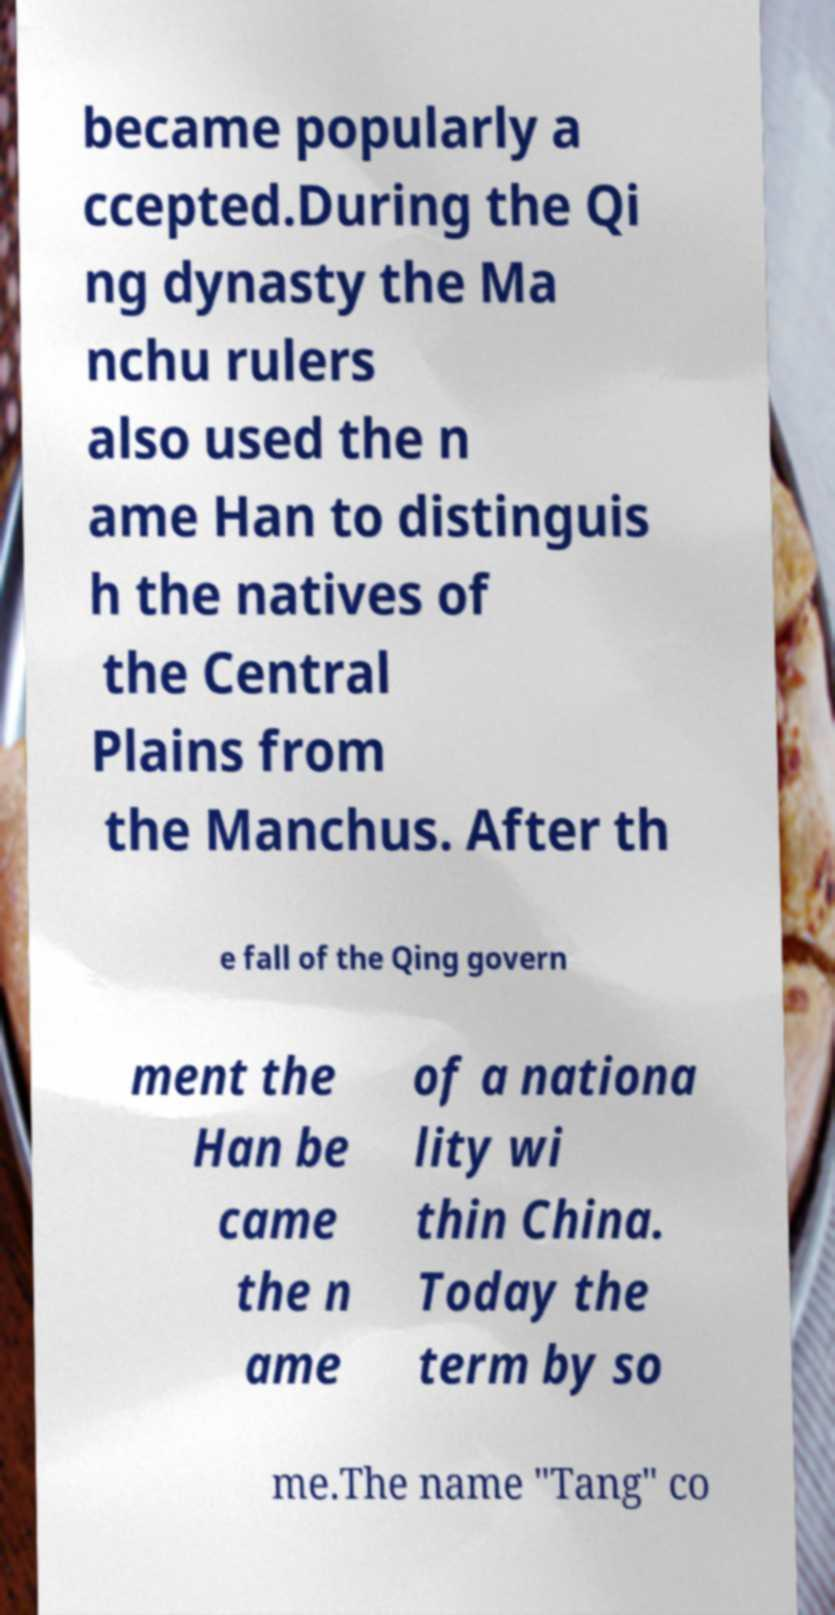Please read and relay the text visible in this image. What does it say? became popularly a ccepted.During the Qi ng dynasty the Ma nchu rulers also used the n ame Han to distinguis h the natives of the Central Plains from the Manchus. After th e fall of the Qing govern ment the Han be came the n ame of a nationa lity wi thin China. Today the term by so me.The name "Tang" co 